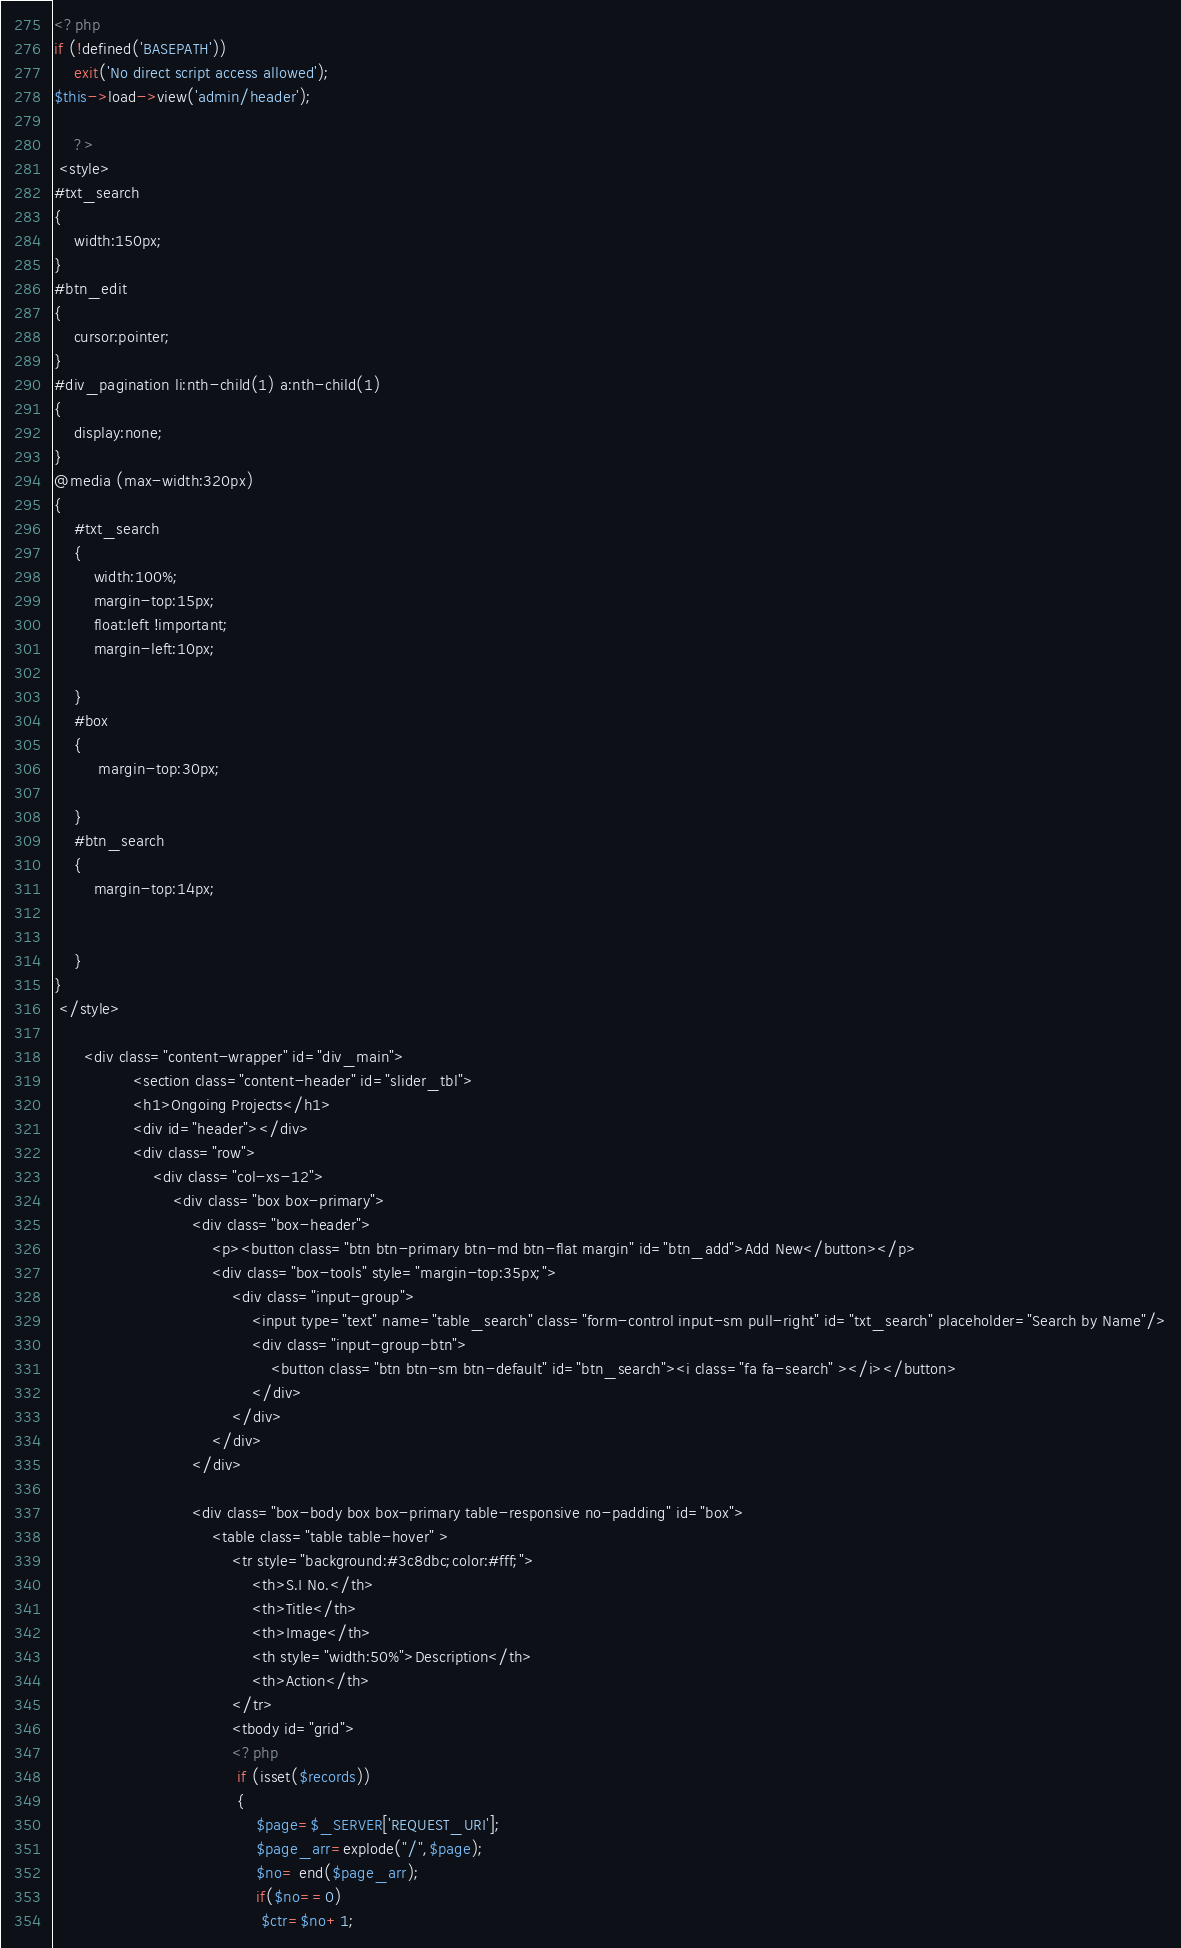<code> <loc_0><loc_0><loc_500><loc_500><_PHP_><?php
if (!defined('BASEPATH'))
    exit('No direct script access allowed');
$this->load->view('admin/header');

	?>
 <style> 
#txt_search
{
	width:150px;
} 
#btn_edit
{
	cursor:pointer;
}
#div_pagination li:nth-child(1) a:nth-child(1)
{
	display:none;
}		 
@media (max-width:320px)
{
	#txt_search
	{
		width:100%;
		margin-top:15px;
		float:left !important;
		margin-left:10px;
		
	}  
	#box
	{
		 margin-top:30px;
	
	}
	#btn_search
	{
		margin-top:14px;
		
		
	}		
} 
 </style>
	
      <div class="content-wrapper" id="div_main">
				<section class="content-header" id="slider_tbl">
				<h1>Ongoing Projects</h1>
				<div id="header"></div>
				<div class="row">
					<div class="col-xs-12">	
						<div class="box box-primary">
							<div class="box-header">
								<p><button class="btn btn-primary btn-md btn-flat margin" id="btn_add">Add New</button></p>
								<div class="box-tools" style="margin-top:35px;">
									<div class="input-group">
										<input type="text" name="table_search" class="form-control input-sm pull-right" id="txt_search" placeholder="Search by Name"/>
										<div class="input-group-btn">
											<button class="btn btn-sm btn-default" id="btn_search"><i class="fa fa-search" ></i></button>
										</div>
									</div>
								</div>
							</div>
							
							<div class="box-body box box-primary table-responsive no-padding" id="box">
								<table class="table table-hover" >
									<tr style="background:#3c8dbc;color:#fff;">
										<th>S.I No.</th>
										<th>Title</th>
										<th>Image</th>
										<th style="width:50%">Description</th>
										<th>Action</th>
									</tr>
									<tbody id="grid">
									<?php 
									 if (isset($records))
									 {
										 $page=$_SERVER['REQUEST_URI'];
										 $page_arr=explode("/",$page);
										 $no= end($page_arr);
										 if($no==0)
										  $ctr=$no+1;</code> 